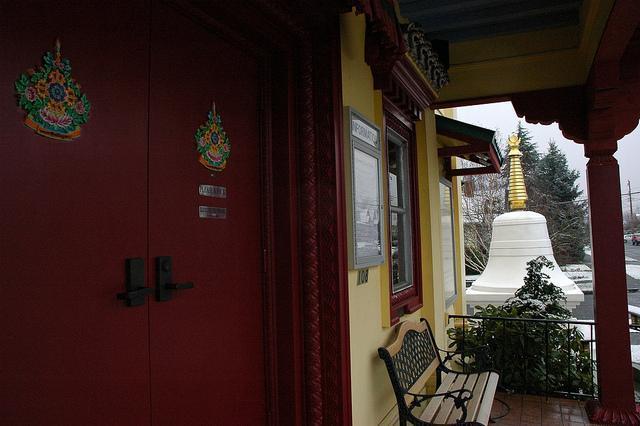How many of these people are women?
Give a very brief answer. 0. 